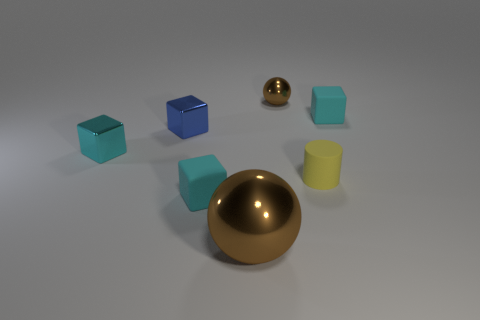Subtract all tiny cyan blocks. How many blocks are left? 1 Add 3 large red rubber cylinders. How many objects exist? 10 Subtract all blue blocks. How many blocks are left? 3 Subtract all blocks. How many objects are left? 3 Subtract 1 blocks. How many blocks are left? 3 Subtract all green balls. Subtract all red cylinders. How many balls are left? 2 Subtract all cyan cylinders. How many cyan blocks are left? 3 Subtract all big gray shiny objects. Subtract all cyan things. How many objects are left? 4 Add 3 tiny blue shiny blocks. How many tiny blue shiny blocks are left? 4 Add 5 cyan objects. How many cyan objects exist? 8 